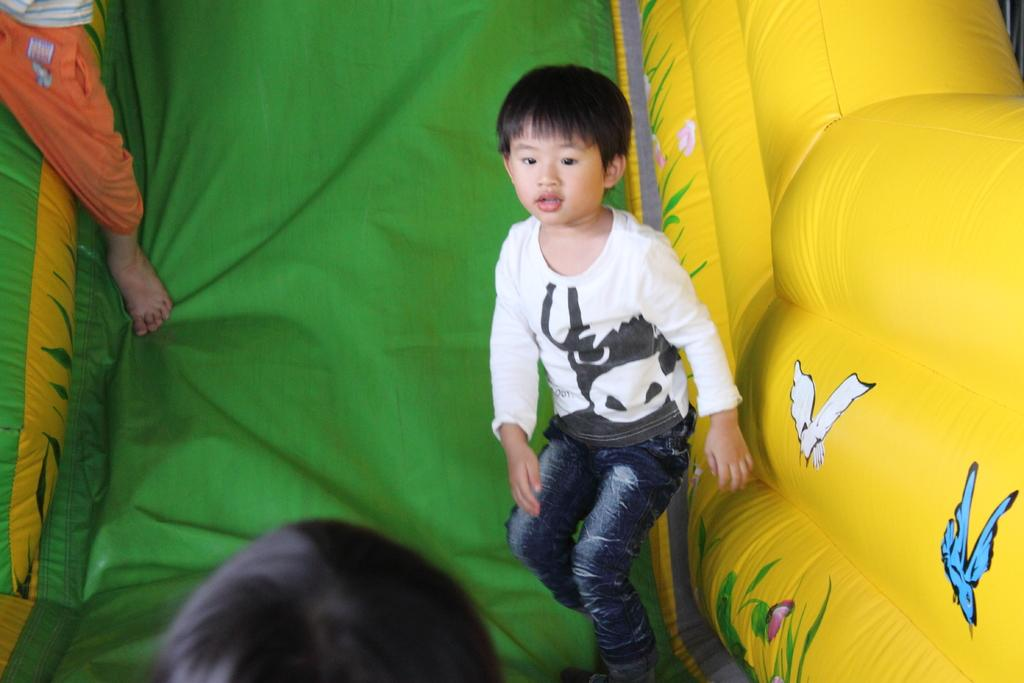How many people are in the image? There are three people in the image. What is the main feature in the image? There is a balloon slide in the image. What creatures can be seen on the slide? Birds are present on the slide. What type of vegetation is visible on the slide? Plants are visible on the slide. Are there any other animals on the slide besides the birds? Yes, there is a butterfly on the slide. What type of canvas is used to create the scene in the image? There is no canvas present in the image; it is a photograph or digital representation of a scene. 